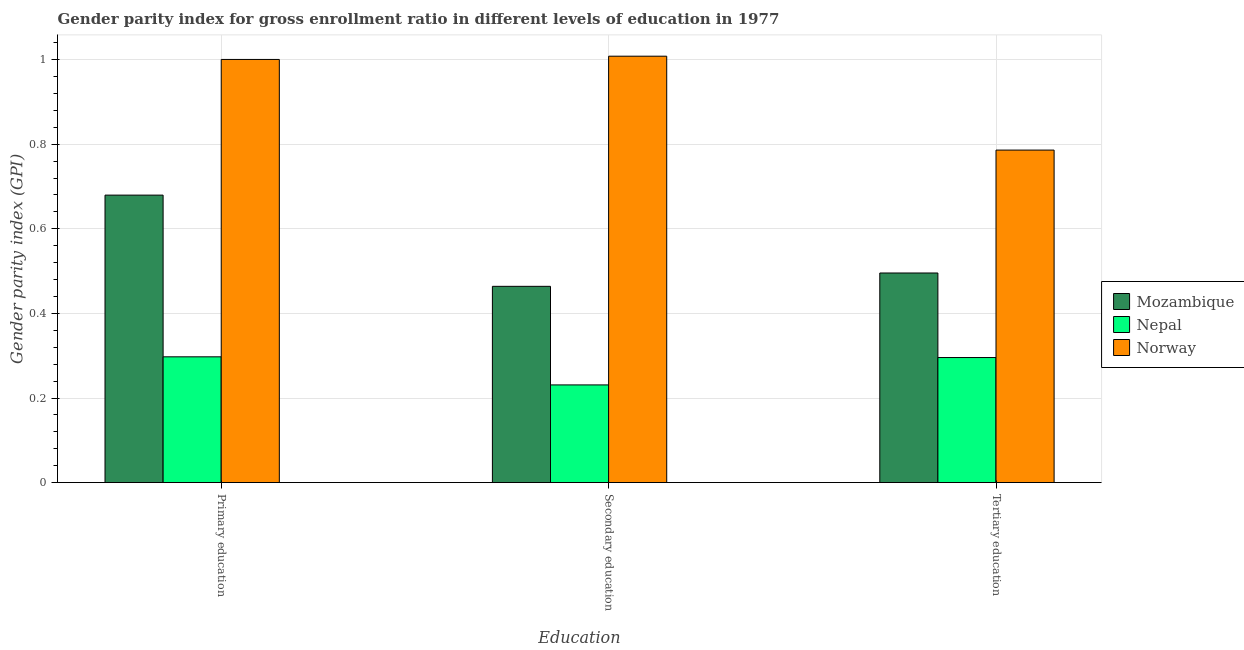How many groups of bars are there?
Ensure brevity in your answer.  3. Are the number of bars per tick equal to the number of legend labels?
Offer a very short reply. Yes. How many bars are there on the 1st tick from the right?
Provide a short and direct response. 3. What is the label of the 1st group of bars from the left?
Offer a terse response. Primary education. What is the gender parity index in primary education in Norway?
Offer a terse response. 1. Across all countries, what is the maximum gender parity index in primary education?
Ensure brevity in your answer.  1. Across all countries, what is the minimum gender parity index in primary education?
Your answer should be compact. 0.3. In which country was the gender parity index in primary education maximum?
Ensure brevity in your answer.  Norway. In which country was the gender parity index in tertiary education minimum?
Provide a succinct answer. Nepal. What is the total gender parity index in tertiary education in the graph?
Make the answer very short. 1.58. What is the difference between the gender parity index in primary education in Mozambique and that in Norway?
Keep it short and to the point. -0.32. What is the difference between the gender parity index in primary education in Nepal and the gender parity index in tertiary education in Norway?
Offer a very short reply. -0.49. What is the average gender parity index in tertiary education per country?
Keep it short and to the point. 0.53. What is the difference between the gender parity index in tertiary education and gender parity index in secondary education in Mozambique?
Your answer should be compact. 0.03. In how many countries, is the gender parity index in primary education greater than 0.2 ?
Offer a very short reply. 3. What is the ratio of the gender parity index in primary education in Mozambique to that in Norway?
Your answer should be compact. 0.68. Is the difference between the gender parity index in primary education in Norway and Mozambique greater than the difference between the gender parity index in tertiary education in Norway and Mozambique?
Your answer should be compact. Yes. What is the difference between the highest and the second highest gender parity index in secondary education?
Provide a short and direct response. 0.54. What is the difference between the highest and the lowest gender parity index in secondary education?
Make the answer very short. 0.78. Is the sum of the gender parity index in secondary education in Mozambique and Norway greater than the maximum gender parity index in primary education across all countries?
Make the answer very short. Yes. What does the 1st bar from the right in Secondary education represents?
Provide a short and direct response. Norway. How many bars are there?
Your answer should be very brief. 9. What is the difference between two consecutive major ticks on the Y-axis?
Give a very brief answer. 0.2. Does the graph contain any zero values?
Make the answer very short. No. Does the graph contain grids?
Ensure brevity in your answer.  Yes. Where does the legend appear in the graph?
Your answer should be compact. Center right. How are the legend labels stacked?
Keep it short and to the point. Vertical. What is the title of the graph?
Ensure brevity in your answer.  Gender parity index for gross enrollment ratio in different levels of education in 1977. What is the label or title of the X-axis?
Provide a short and direct response. Education. What is the label or title of the Y-axis?
Offer a terse response. Gender parity index (GPI). What is the Gender parity index (GPI) in Mozambique in Primary education?
Your response must be concise. 0.68. What is the Gender parity index (GPI) of Nepal in Primary education?
Provide a succinct answer. 0.3. What is the Gender parity index (GPI) of Norway in Primary education?
Your answer should be compact. 1. What is the Gender parity index (GPI) of Mozambique in Secondary education?
Provide a short and direct response. 0.46. What is the Gender parity index (GPI) of Nepal in Secondary education?
Your response must be concise. 0.23. What is the Gender parity index (GPI) in Norway in Secondary education?
Your response must be concise. 1.01. What is the Gender parity index (GPI) in Mozambique in Tertiary education?
Your answer should be compact. 0.5. What is the Gender parity index (GPI) of Nepal in Tertiary education?
Offer a very short reply. 0.3. What is the Gender parity index (GPI) in Norway in Tertiary education?
Ensure brevity in your answer.  0.79. Across all Education, what is the maximum Gender parity index (GPI) of Mozambique?
Provide a succinct answer. 0.68. Across all Education, what is the maximum Gender parity index (GPI) of Nepal?
Your answer should be compact. 0.3. Across all Education, what is the maximum Gender parity index (GPI) of Norway?
Offer a very short reply. 1.01. Across all Education, what is the minimum Gender parity index (GPI) of Mozambique?
Provide a short and direct response. 0.46. Across all Education, what is the minimum Gender parity index (GPI) of Nepal?
Provide a succinct answer. 0.23. Across all Education, what is the minimum Gender parity index (GPI) in Norway?
Your answer should be compact. 0.79. What is the total Gender parity index (GPI) of Mozambique in the graph?
Provide a succinct answer. 1.64. What is the total Gender parity index (GPI) in Nepal in the graph?
Ensure brevity in your answer.  0.82. What is the total Gender parity index (GPI) in Norway in the graph?
Your response must be concise. 2.79. What is the difference between the Gender parity index (GPI) in Mozambique in Primary education and that in Secondary education?
Offer a terse response. 0.22. What is the difference between the Gender parity index (GPI) in Nepal in Primary education and that in Secondary education?
Make the answer very short. 0.07. What is the difference between the Gender parity index (GPI) in Norway in Primary education and that in Secondary education?
Offer a very short reply. -0.01. What is the difference between the Gender parity index (GPI) of Mozambique in Primary education and that in Tertiary education?
Make the answer very short. 0.18. What is the difference between the Gender parity index (GPI) in Nepal in Primary education and that in Tertiary education?
Your answer should be compact. 0. What is the difference between the Gender parity index (GPI) in Norway in Primary education and that in Tertiary education?
Provide a short and direct response. 0.21. What is the difference between the Gender parity index (GPI) in Mozambique in Secondary education and that in Tertiary education?
Keep it short and to the point. -0.03. What is the difference between the Gender parity index (GPI) of Nepal in Secondary education and that in Tertiary education?
Give a very brief answer. -0.06. What is the difference between the Gender parity index (GPI) of Norway in Secondary education and that in Tertiary education?
Make the answer very short. 0.22. What is the difference between the Gender parity index (GPI) of Mozambique in Primary education and the Gender parity index (GPI) of Nepal in Secondary education?
Make the answer very short. 0.45. What is the difference between the Gender parity index (GPI) of Mozambique in Primary education and the Gender parity index (GPI) of Norway in Secondary education?
Your answer should be compact. -0.33. What is the difference between the Gender parity index (GPI) in Nepal in Primary education and the Gender parity index (GPI) in Norway in Secondary education?
Provide a succinct answer. -0.71. What is the difference between the Gender parity index (GPI) of Mozambique in Primary education and the Gender parity index (GPI) of Nepal in Tertiary education?
Provide a short and direct response. 0.38. What is the difference between the Gender parity index (GPI) of Mozambique in Primary education and the Gender parity index (GPI) of Norway in Tertiary education?
Offer a terse response. -0.11. What is the difference between the Gender parity index (GPI) of Nepal in Primary education and the Gender parity index (GPI) of Norway in Tertiary education?
Your answer should be compact. -0.49. What is the difference between the Gender parity index (GPI) of Mozambique in Secondary education and the Gender parity index (GPI) of Nepal in Tertiary education?
Offer a terse response. 0.17. What is the difference between the Gender parity index (GPI) of Mozambique in Secondary education and the Gender parity index (GPI) of Norway in Tertiary education?
Offer a very short reply. -0.32. What is the difference between the Gender parity index (GPI) of Nepal in Secondary education and the Gender parity index (GPI) of Norway in Tertiary education?
Your response must be concise. -0.56. What is the average Gender parity index (GPI) of Mozambique per Education?
Your response must be concise. 0.55. What is the average Gender parity index (GPI) in Nepal per Education?
Offer a very short reply. 0.27. What is the average Gender parity index (GPI) in Norway per Education?
Give a very brief answer. 0.93. What is the difference between the Gender parity index (GPI) in Mozambique and Gender parity index (GPI) in Nepal in Primary education?
Your answer should be compact. 0.38. What is the difference between the Gender parity index (GPI) in Mozambique and Gender parity index (GPI) in Norway in Primary education?
Your answer should be very brief. -0.32. What is the difference between the Gender parity index (GPI) in Nepal and Gender parity index (GPI) in Norway in Primary education?
Make the answer very short. -0.7. What is the difference between the Gender parity index (GPI) in Mozambique and Gender parity index (GPI) in Nepal in Secondary education?
Provide a short and direct response. 0.23. What is the difference between the Gender parity index (GPI) of Mozambique and Gender parity index (GPI) of Norway in Secondary education?
Keep it short and to the point. -0.54. What is the difference between the Gender parity index (GPI) in Nepal and Gender parity index (GPI) in Norway in Secondary education?
Your answer should be very brief. -0.78. What is the difference between the Gender parity index (GPI) in Mozambique and Gender parity index (GPI) in Nepal in Tertiary education?
Your response must be concise. 0.2. What is the difference between the Gender parity index (GPI) of Mozambique and Gender parity index (GPI) of Norway in Tertiary education?
Offer a terse response. -0.29. What is the difference between the Gender parity index (GPI) of Nepal and Gender parity index (GPI) of Norway in Tertiary education?
Provide a succinct answer. -0.49. What is the ratio of the Gender parity index (GPI) in Mozambique in Primary education to that in Secondary education?
Offer a terse response. 1.46. What is the ratio of the Gender parity index (GPI) in Nepal in Primary education to that in Secondary education?
Give a very brief answer. 1.29. What is the ratio of the Gender parity index (GPI) of Norway in Primary education to that in Secondary education?
Offer a terse response. 0.99. What is the ratio of the Gender parity index (GPI) in Mozambique in Primary education to that in Tertiary education?
Keep it short and to the point. 1.37. What is the ratio of the Gender parity index (GPI) of Nepal in Primary education to that in Tertiary education?
Provide a short and direct response. 1.01. What is the ratio of the Gender parity index (GPI) in Norway in Primary education to that in Tertiary education?
Make the answer very short. 1.27. What is the ratio of the Gender parity index (GPI) in Mozambique in Secondary education to that in Tertiary education?
Offer a very short reply. 0.94. What is the ratio of the Gender parity index (GPI) of Nepal in Secondary education to that in Tertiary education?
Give a very brief answer. 0.78. What is the ratio of the Gender parity index (GPI) of Norway in Secondary education to that in Tertiary education?
Offer a very short reply. 1.28. What is the difference between the highest and the second highest Gender parity index (GPI) in Mozambique?
Give a very brief answer. 0.18. What is the difference between the highest and the second highest Gender parity index (GPI) in Nepal?
Your answer should be compact. 0. What is the difference between the highest and the second highest Gender parity index (GPI) of Norway?
Your response must be concise. 0.01. What is the difference between the highest and the lowest Gender parity index (GPI) of Mozambique?
Your answer should be compact. 0.22. What is the difference between the highest and the lowest Gender parity index (GPI) of Nepal?
Your answer should be very brief. 0.07. What is the difference between the highest and the lowest Gender parity index (GPI) of Norway?
Provide a short and direct response. 0.22. 